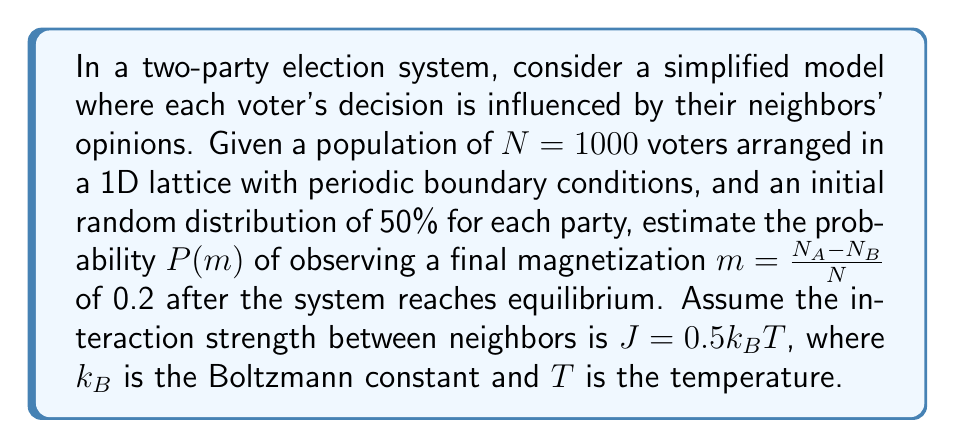What is the answer to this math problem? To solve this problem, we'll use the Ising model from statistical mechanics:

1. The Hamiltonian for the system is:
   $$H = -J\sum_{<i,j>} s_is_j$$
   where $s_i = \pm1$ represents the voter's choice.

2. The probability of a specific configuration is given by the Boltzmann distribution:
   $$P(\{s_i\}) = \frac{1}{Z} e^{-\beta H}$$
   where $\beta = \frac{1}{k_BT}$ and $Z$ is the partition function.

3. For a 1D Ising model, the exact solution for the magnetization distribution is:
   $$P(m) \propto \exp\left(-N\frac{m^2}{2\chi}\right)$$
   where $\chi$ is the magnetic susceptibility.

4. In the high-temperature limit (weak coupling), $\chi \approx \frac{1}{k_BT}(1 + \tanh(\beta J))$.

5. Substituting the given values:
   $$\beta J = \frac{J}{k_BT} = 0.5$$
   $$\chi \approx \frac{1}{k_BT}(1 + \tanh(0.5)) \approx 1.462$$

6. The probability of observing $m = 0.2$ is proportional to:
   $$P(0.2) \propto \exp\left(-1000 \cdot \frac{0.2^2}{2 \cdot 1.462}\right) \approx 0.0273$$

7. To get the actual probability, we need to normalize this value by integrating over all possible $m$ values. However, the relative probability compared to the equilibrium state ($m = 0$) is more informative:
   $$\frac{P(0.2)}{P(0)} = \exp\left(-1000 \cdot \frac{0.2^2}{2 \cdot 1.462}\right) \approx 0.0273$$

This means the probability of observing $m = 0.2$ is about 2.73% of the probability of observing $m = 0$.
Answer: $P(0.2) \approx 0.0273 \cdot P(0)$ 